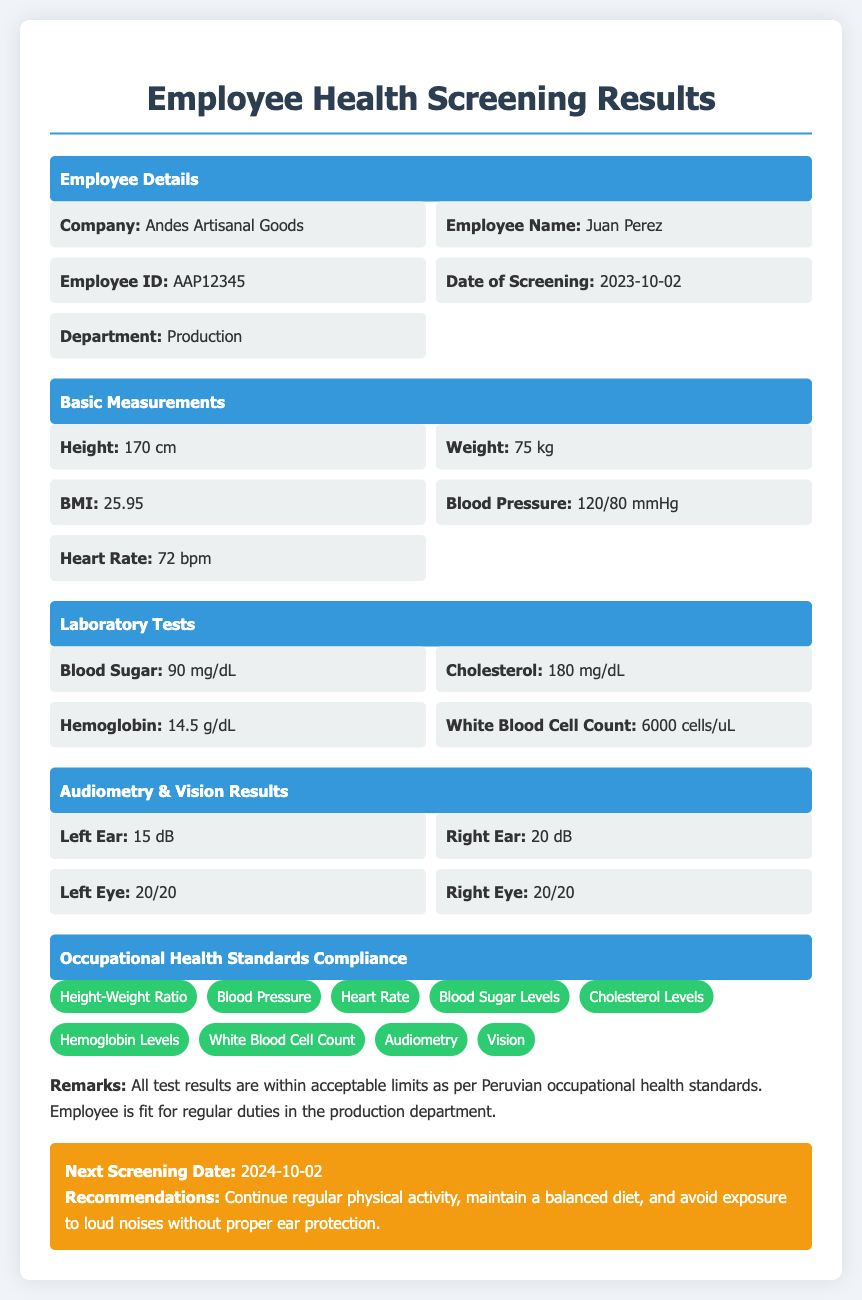what is the employee's name? The employee's name is listed in the document under the Employee Details section.
Answer: Juan Perez what is the employee's ID? The employee's ID can be found in the Employee Details section of the document.
Answer: AAP12345 when was the screening date? The date of the screening is specified in the Employee Details section.
Answer: 2023-10-02 what was the employee's BMI? The BMI is mentioned in the Basic Measurements section of the document.
Answer: 25.95 are the blood pressure levels compliant? Compliance information is stated in the Occupational Health Standards Compliance section.
Answer: Yes how much does the employee weigh? The weight of the employee is provided in the Basic Measurements section.
Answer: 75 kg what recommendations were made for the employee? Recommendations are listed in the last section of the document.
Answer: Continue regular physical activity, maintain a balanced diet, and avoid exposure to loud noises without proper ear protection what is the cholesterol level? The cholesterol level is given in the Laboratory Tests section of the document.
Answer: 180 mg/dL what is the next screening date? The next screening date is mentioned in the recommendations section of the document.
Answer: 2024-10-02 